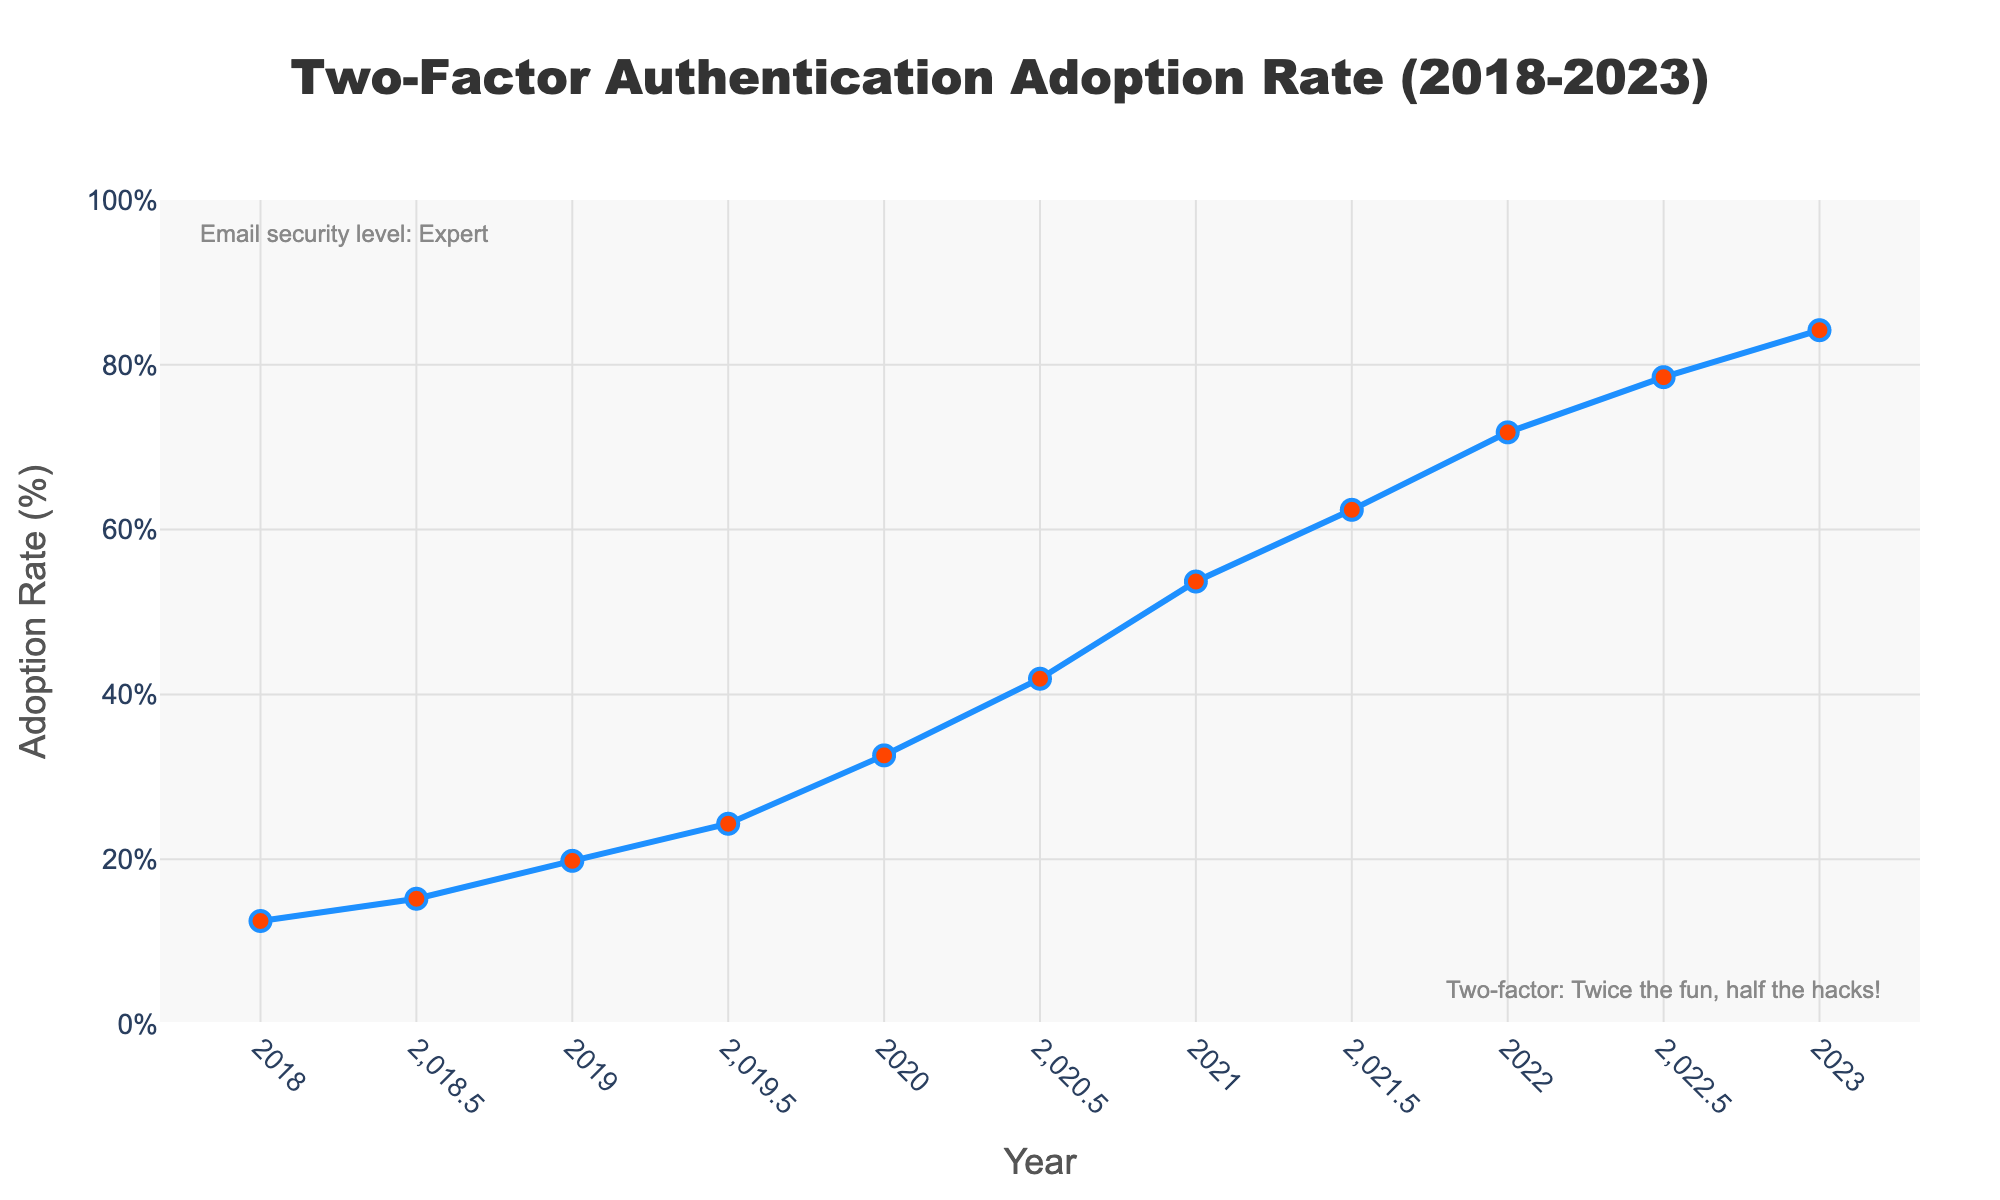What was the adoption rate of two-factor authentication in 2018? Look at the data point corresponding to 2018 on the x-axis and read the value on the y-axis.
Answer: 12.5% What is the difference in adoption rate between 2020 and 2023? Identify the adoption rates for 2020 (32.6%) and 2023 (84.2%). Subtract the 2020 rate from the 2023 rate: 84.2 - 32.6.
Answer: 51.6 Which year saw the highest adoption rate increase in the first half of the year? Compare the increases in adoption rate between consecutive half-year points: 2018 (2.7), 2019 (4.5), 2020 (9.3), 2021 (8.7), 2022 (6.7). The highest increase is from 2019.5 to 2020.
Answer: 2020 How does the adoption rate in 2021.5 compare to that in 2020? Look at the data points for 2021.5 (62.4%) and 2020 (32.6%). Calculate the difference: 62.4 - 32.6.
Answer: 29.8% higher Does the adoption rate exceed 50% before 2021? Identify the data points before 2021 and check if any adoption rate is above 50%.
Answer: No What is the average adoption rate from 2020 to 2021.5? Identify the data points: 2020 (32.6%), 2020.5 (41.9%), 2021 (53.7%), 2021.5 (62.4%). Calculate their average: (32.6 + 41.9 + 53.7 + 62.4) / 4.
Answer: 47.65% Which half-year period had the smallest increase in adoption rate? Compare the increases: 2018 (2.7), 2019 (4.5), 2020 (9.3), 2021 (8.7), 2022 (6.7). The smallest increase is from 2022.5 to 2023.
Answer: 2022.5-2023 Identify the rate of change in adoption from 2018.5 to 2019.5? Identify the data points: 2018.5 (15.2%) and 2019.5 (24.3%), calculate the difference: 24.3 - 15.2.
Answer: 9.1% How many full years showed an adoption rate increase of over 10 percentage points? Identify the adoption increases between adjacent full years: 2018-2019 (7.3), 2019-2020 (12.8), 2020-2021 (21.1), 2021-2022 (18.1). Count the years with increases over 10%.
Answer: 3 years 